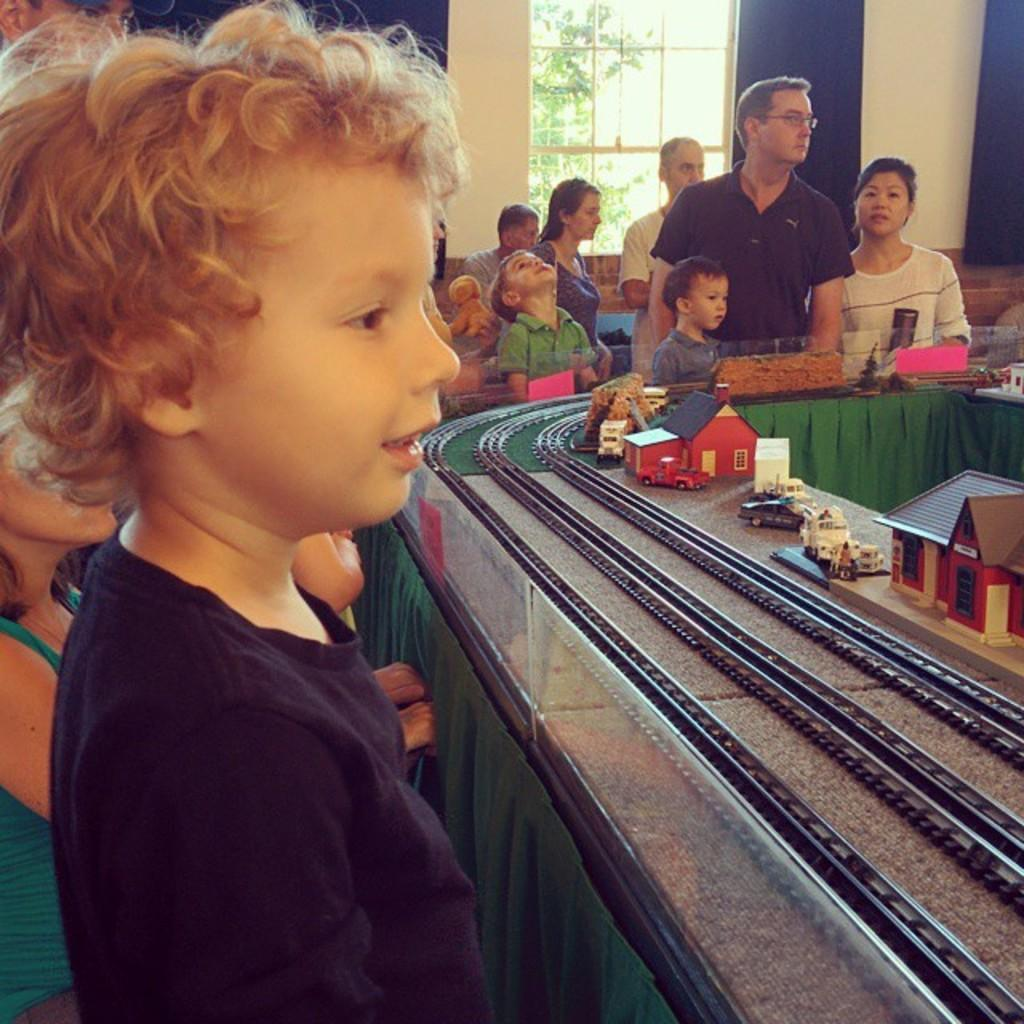How many people are in the group visible in the image? There is a group of people standing in the image, but the exact number cannot be determined from the provided facts. What type of toys can be seen on the table in the image? There are toy houses, toy railway tracks, and toy vehicles on the table in the image. What can be seen in the background of the image? There is a wall, a window, and a tree in the background of the image. How many stars can be seen in the sky in the image? There is no mention of stars or a sky in the image; only a wall, a window, and a tree are mentioned in the background. What type of lizards are crawling on the toy houses in the image? There are no lizards present in the image; only toy houses, toy railway tracks, and toy vehicles are mentioned on the table. 